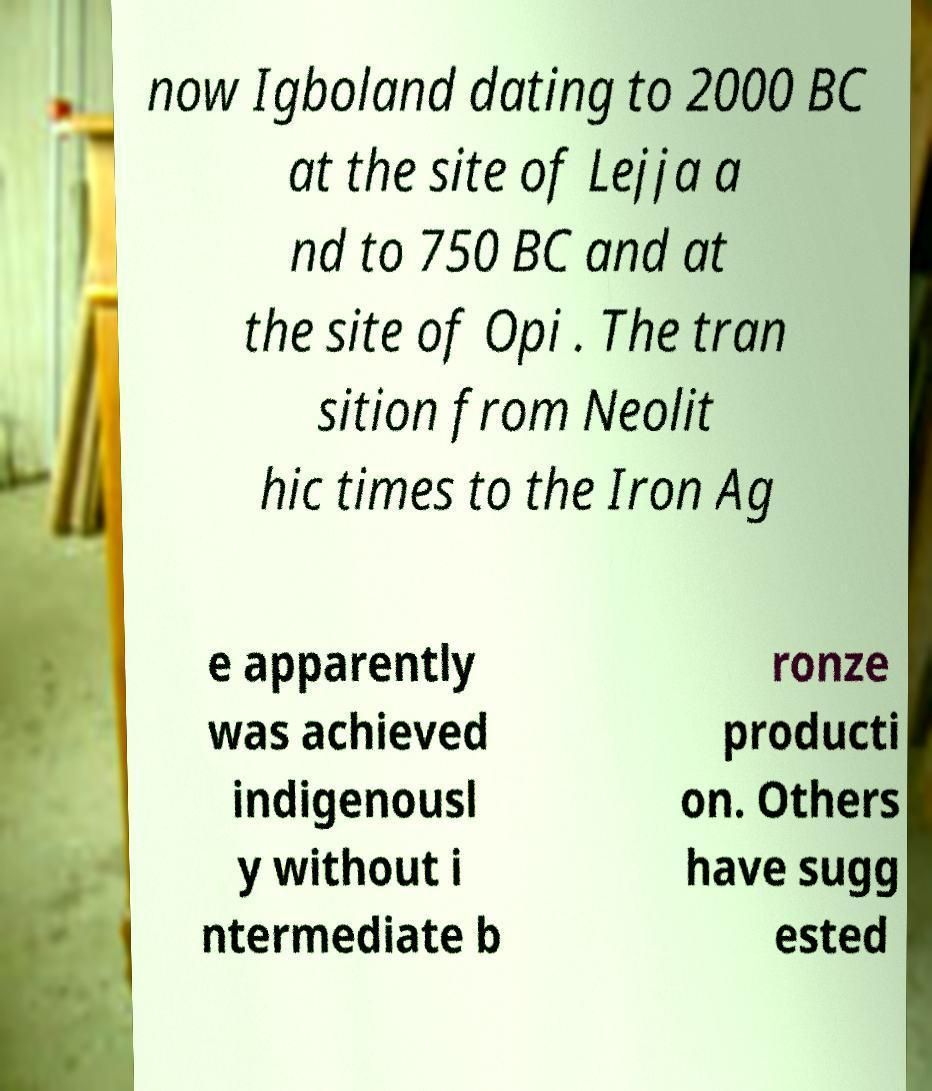For documentation purposes, I need the text within this image transcribed. Could you provide that? now Igboland dating to 2000 BC at the site of Lejja a nd to 750 BC and at the site of Opi . The tran sition from Neolit hic times to the Iron Ag e apparently was achieved indigenousl y without i ntermediate b ronze producti on. Others have sugg ested 